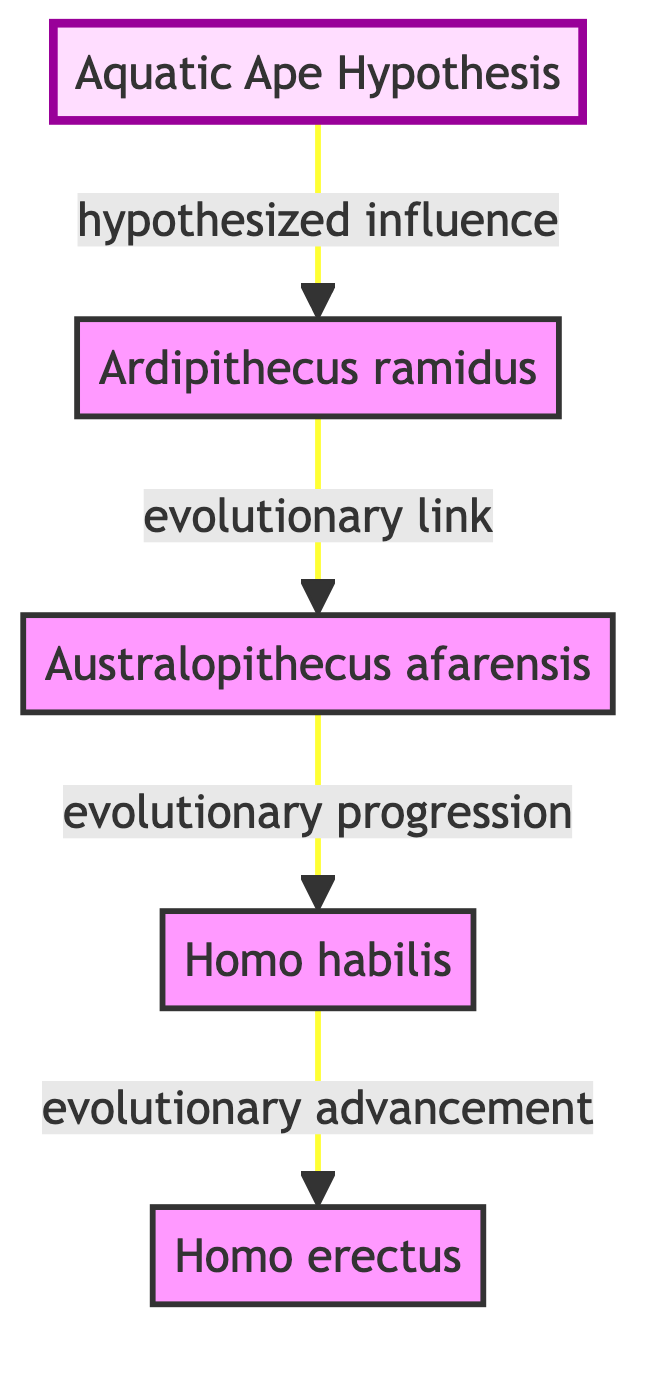What is the main hypothesis depicted in the diagram? The node labeled "1" identifies the main topic as "Aquatic Ape Hypothesis." This is the foundational concept from which other nodes (human ancestors) derive influence or evolutionary links.
Answer: Aquatic Ape Hypothesis How many nodes are present in the diagram? By counting the nodes listed (1 through 5), there are a total of five distinct entities represented in the diagram.
Answer: 5 What is the relationship between "Homo habilis" and "Homo erectus"? The edge between nodes "4" and "5" indicates an "evolutionary advancement" relationship, showing that "Homo habilis" is followed by "Homo erectus" in evolutionary terms.
Answer: evolutionary advancement Which species is hypothesized to have influenced "Ardipithecus ramidus"? The edge from node "1" to node "2" clearly states the relationship as "hypothesized influence," indicating that the Aquatic Ape Hypothesis impacts "Ardipithecus ramidus."
Answer: hypothesized influence What is the evolutionary progression from "Australopithecus afarensis"? Following the arrows from node "3" (Australopithecus afarensis) leads to node "4," stating it shows an evolutionary link to "Homo habilis," marking progress in the lineage.
Answer: evolutionary progression Which species is known for both bipedalism and tool use? The description of node "4" (Homo habilis) highlights that it displayed advanced tool use, making it the correct identification for this characteristic among the listed species.
Answer: Homo habilis How does “Homo erectus” differ in development from “Ardipithecus ramidus”? The relationship flow from "1" to "2" indicates a hypothesized influence while "4" to "5" shows evolutionary advancement. This implies that "Homo erectus" has advanced further in bipedalism than "Ardipithecus ramidus."
Answer: advanced bipedalism What type of node is the “Aquatic Ape Hypothesis”? The diagram indicates that node "1" is styled differently, marked as a hypothesis, denoted by the specific class definition labeled "hypothesis."
Answer: hypothesis What is the central theme that connects all the nodes? The edges reveal a continuous evolutionary link that suggests a themed connection of bipedalism development influenced by aquatic environments, stemming from the Aquatic Ape Hypothesis.
Answer: bipedalism development 